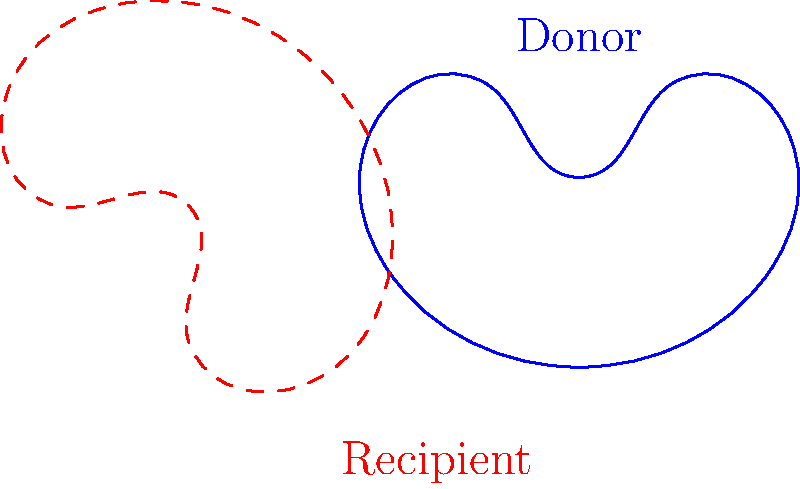As a neurosurgeon preparing for an organ transplant, you need to determine the angle of rotation required to align the donor organ with the recipient's orientation. The diagram shows the donor organ (solid blue) and the recipient's required orientation (dashed red). What is the angle $\theta$ of rotation needed to transform the donor organ to match the recipient's orientation? To solve this problem, we need to analyze the rotational transformation between the donor organ and the recipient's orientation:

1. Observe that the rotation is counterclockwise from the donor organ to the recipient's orientation.

2. The angle of rotation is marked as $\theta$ in the diagram.

3. In geometry, a full rotation is 360°.

4. The diagram shows that the rotation is more than a quarter turn (90°) but less than a half turn (180°).

5. By examining the orientation of the organ shapes, we can see that the rotation is precisely 3/8 of a full turn.

6. To calculate the angle in degrees:
   $$\theta = \frac{3}{8} \times 360° = 135°$$

Therefore, the angle of rotation needed to transform the donor organ to match the recipient's orientation is 135°.
Answer: 135° 